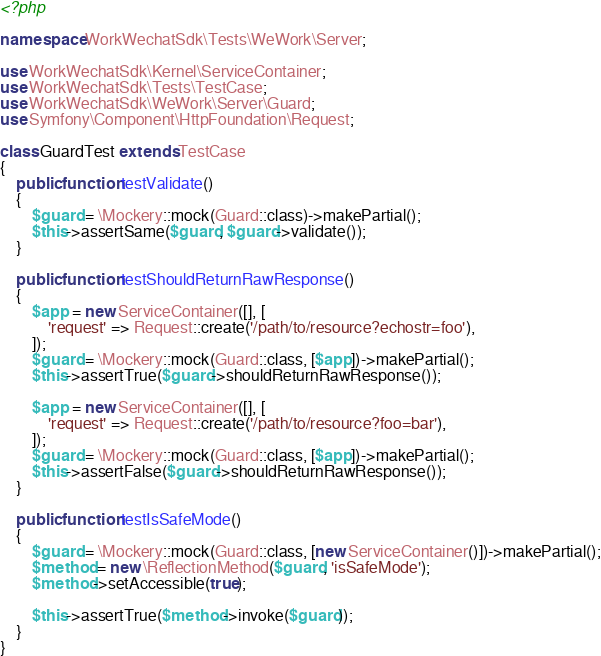Convert code to text. <code><loc_0><loc_0><loc_500><loc_500><_PHP_><?php

namespace WorkWechatSdk\Tests\WeWork\Server;

use WorkWechatSdk\Kernel\ServiceContainer;
use WorkWechatSdk\Tests\TestCase;
use WorkWechatSdk\WeWork\Server\Guard;
use Symfony\Component\HttpFoundation\Request;

class GuardTest extends TestCase
{
    public function testValidate()
    {
        $guard = \Mockery::mock(Guard::class)->makePartial();
        $this->assertSame($guard, $guard->validate());
    }

    public function testShouldReturnRawResponse()
    {
        $app = new ServiceContainer([], [
            'request' => Request::create('/path/to/resource?echostr=foo'),
        ]);
        $guard = \Mockery::mock(Guard::class, [$app])->makePartial();
        $this->assertTrue($guard->shouldReturnRawResponse());

        $app = new ServiceContainer([], [
            'request' => Request::create('/path/to/resource?foo=bar'),
        ]);
        $guard = \Mockery::mock(Guard::class, [$app])->makePartial();
        $this->assertFalse($guard->shouldReturnRawResponse());
    }

    public function testIsSafeMode()
    {
        $guard = \Mockery::mock(Guard::class, [new ServiceContainer()])->makePartial();
        $method = new \ReflectionMethod($guard, 'isSafeMode');
        $method->setAccessible(true);

        $this->assertTrue($method->invoke($guard));
    }
}</code> 